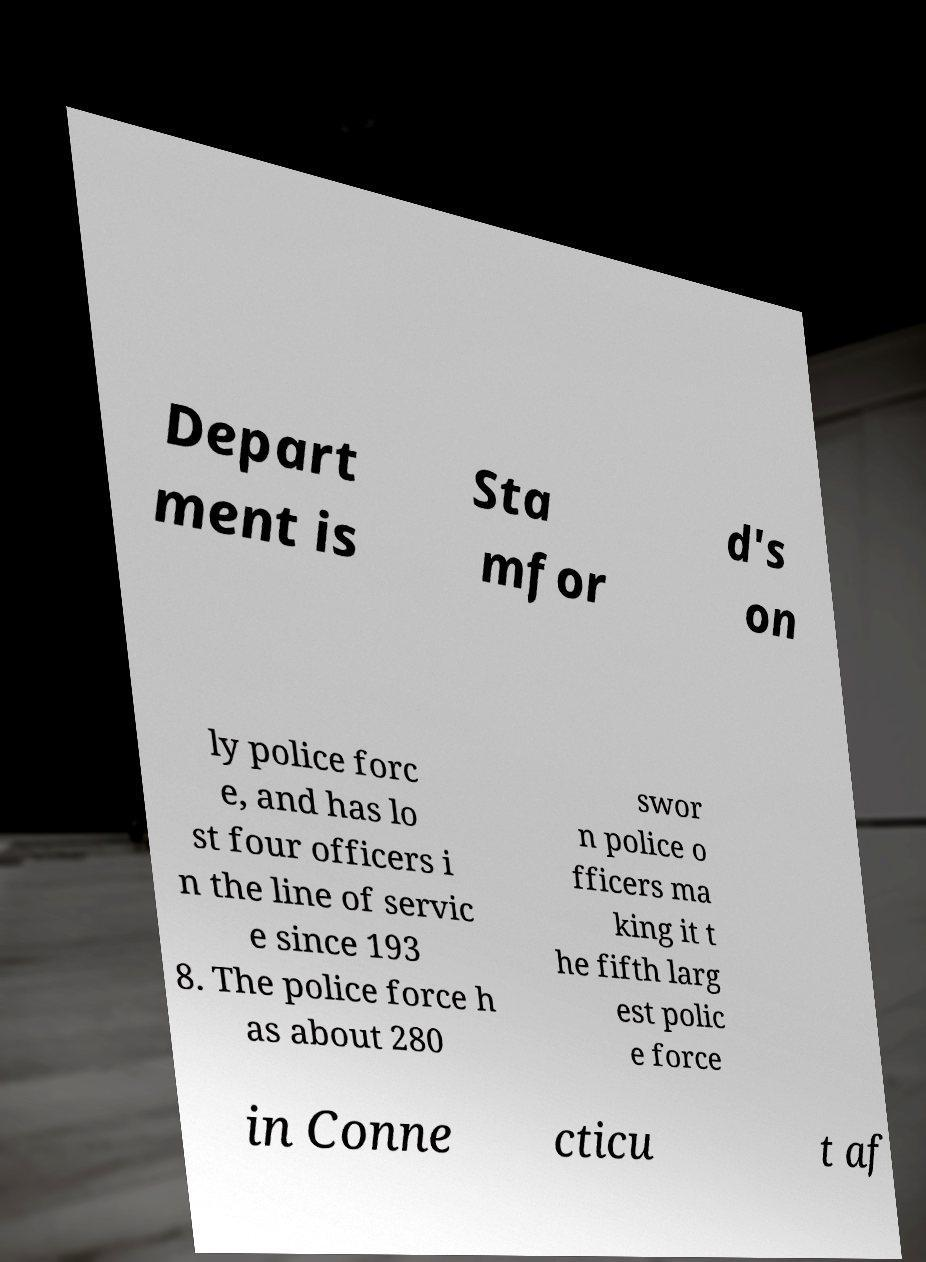Could you assist in decoding the text presented in this image and type it out clearly? Depart ment is Sta mfor d's on ly police forc e, and has lo st four officers i n the line of servic e since 193 8. The police force h as about 280 swor n police o fficers ma king it t he fifth larg est polic e force in Conne cticu t af 